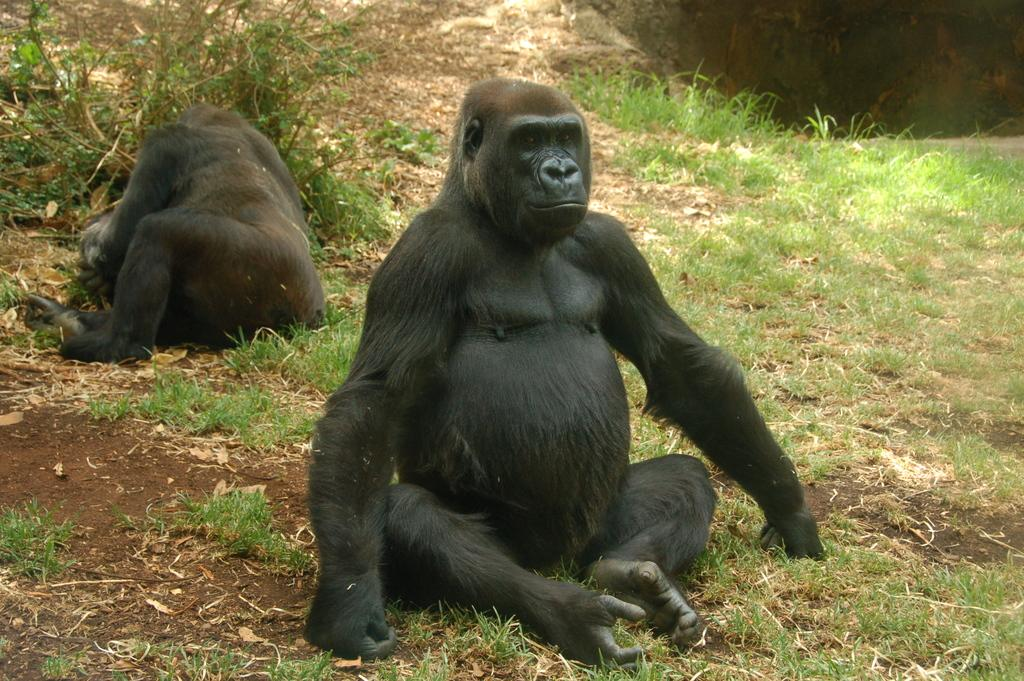What animal is sitting on the grass in the image? There is a monkey sitting on the grass in the image. Are there any other monkeys visible in the image? Yes, there is another monkey visible in the image. What type of vegetation can be seen on the left side of the image? Bushes are present on the left side of the image. What type of lumber is being used to build the monkey's house in the image? There is no mention of a monkey's house or lumber in the image. 